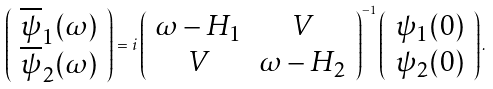Convert formula to latex. <formula><loc_0><loc_0><loc_500><loc_500>\left ( \begin{array} { c } \overline { \psi } _ { 1 } ( \omega ) \\ \overline { \psi } _ { 2 } ( \omega ) \end{array} \right ) = i \left ( \begin{array} { c c } \omega - H _ { 1 } & V \\ V & \omega - H _ { 2 } \end{array} \right ) ^ { - 1 } \left ( \begin{array} { c } \psi _ { 1 } ( 0 ) \\ \psi _ { 2 } ( 0 ) \end{array} \right ) .</formula> 